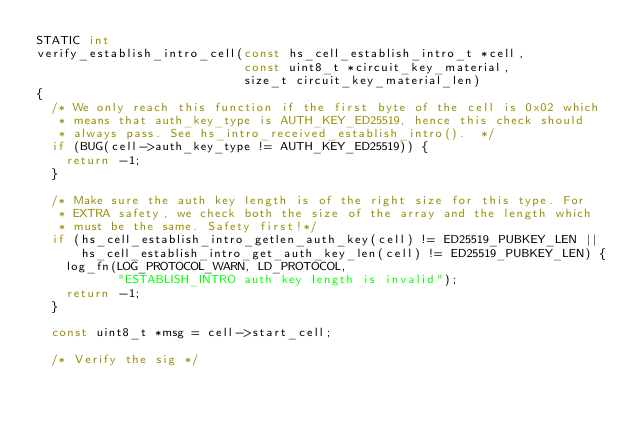Convert code to text. <code><loc_0><loc_0><loc_500><loc_500><_C_>STATIC int
verify_establish_intro_cell(const hs_cell_establish_intro_t *cell,
                            const uint8_t *circuit_key_material,
                            size_t circuit_key_material_len)
{
  /* We only reach this function if the first byte of the cell is 0x02 which
   * means that auth_key_type is AUTH_KEY_ED25519, hence this check should
   * always pass. See hs_intro_received_establish_intro().  */
  if (BUG(cell->auth_key_type != AUTH_KEY_ED25519)) {
    return -1;
  }

  /* Make sure the auth key length is of the right size for this type. For
   * EXTRA safety, we check both the size of the array and the length which
   * must be the same. Safety first!*/
  if (hs_cell_establish_intro_getlen_auth_key(cell) != ED25519_PUBKEY_LEN ||
      hs_cell_establish_intro_get_auth_key_len(cell) != ED25519_PUBKEY_LEN) {
    log_fn(LOG_PROTOCOL_WARN, LD_PROTOCOL,
           "ESTABLISH_INTRO auth key length is invalid");
    return -1;
  }

  const uint8_t *msg = cell->start_cell;

  /* Verify the sig */</code> 